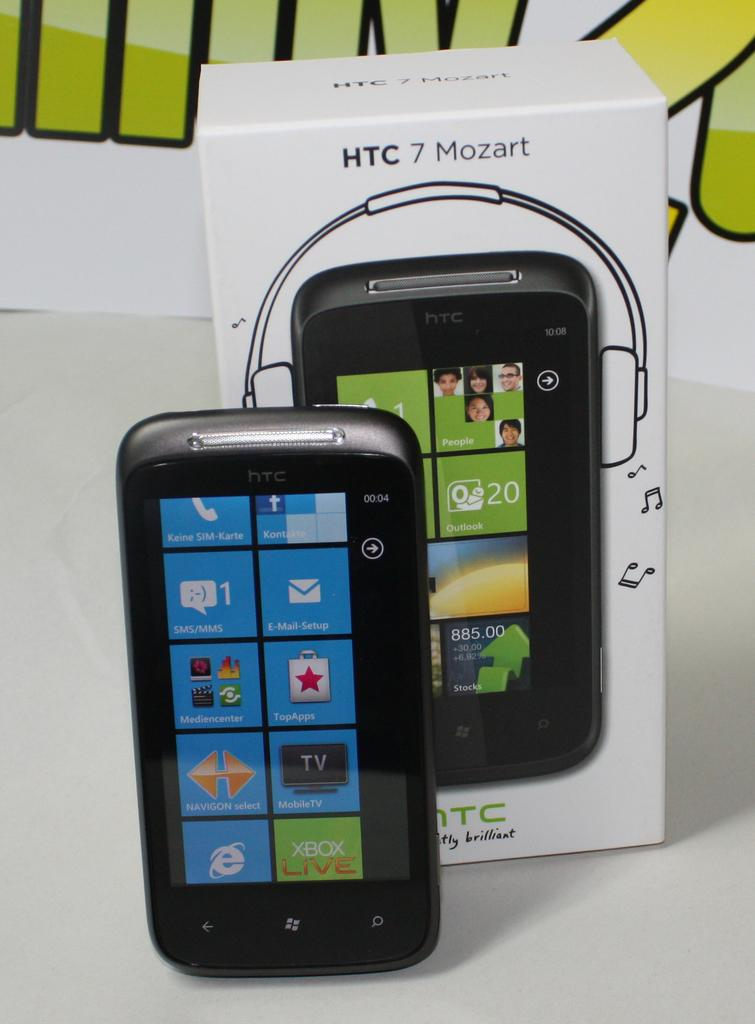<image>
Relay a brief, clear account of the picture shown. A chunky phone with HTC 7 Mozart written on thebox. 